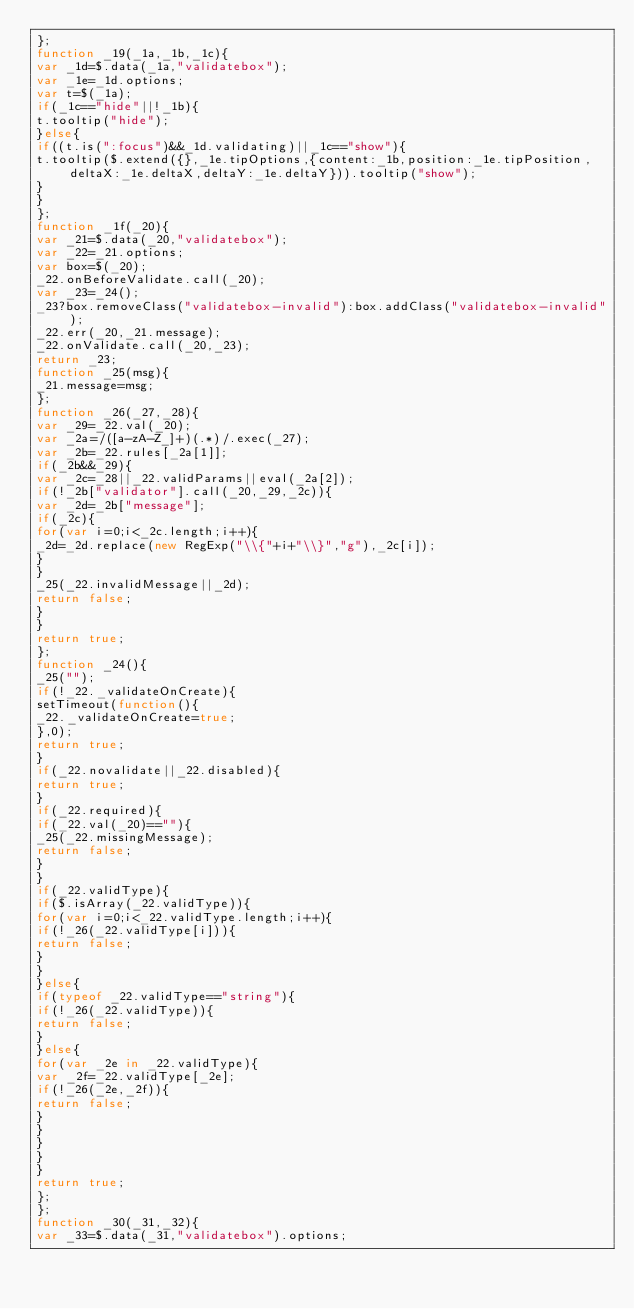<code> <loc_0><loc_0><loc_500><loc_500><_JavaScript_>};
function _19(_1a,_1b,_1c){
var _1d=$.data(_1a,"validatebox");
var _1e=_1d.options;
var t=$(_1a);
if(_1c=="hide"||!_1b){
t.tooltip("hide");
}else{
if((t.is(":focus")&&_1d.validating)||_1c=="show"){
t.tooltip($.extend({},_1e.tipOptions,{content:_1b,position:_1e.tipPosition,deltaX:_1e.deltaX,deltaY:_1e.deltaY})).tooltip("show");
}
}
};
function _1f(_20){
var _21=$.data(_20,"validatebox");
var _22=_21.options;
var box=$(_20);
_22.onBeforeValidate.call(_20);
var _23=_24();
_23?box.removeClass("validatebox-invalid"):box.addClass("validatebox-invalid");
_22.err(_20,_21.message);
_22.onValidate.call(_20,_23);
return _23;
function _25(msg){
_21.message=msg;
};
function _26(_27,_28){
var _29=_22.val(_20);
var _2a=/([a-zA-Z_]+)(.*)/.exec(_27);
var _2b=_22.rules[_2a[1]];
if(_2b&&_29){
var _2c=_28||_22.validParams||eval(_2a[2]);
if(!_2b["validator"].call(_20,_29,_2c)){
var _2d=_2b["message"];
if(_2c){
for(var i=0;i<_2c.length;i++){
_2d=_2d.replace(new RegExp("\\{"+i+"\\}","g"),_2c[i]);
}
}
_25(_22.invalidMessage||_2d);
return false;
}
}
return true;
};
function _24(){
_25("");
if(!_22._validateOnCreate){
setTimeout(function(){
_22._validateOnCreate=true;
},0);
return true;
}
if(_22.novalidate||_22.disabled){
return true;
}
if(_22.required){
if(_22.val(_20)==""){
_25(_22.missingMessage);
return false;
}
}
if(_22.validType){
if($.isArray(_22.validType)){
for(var i=0;i<_22.validType.length;i++){
if(!_26(_22.validType[i])){
return false;
}
}
}else{
if(typeof _22.validType=="string"){
if(!_26(_22.validType)){
return false;
}
}else{
for(var _2e in _22.validType){
var _2f=_22.validType[_2e];
if(!_26(_2e,_2f)){
return false;
}
}
}
}
}
return true;
};
};
function _30(_31,_32){
var _33=$.data(_31,"validatebox").options;</code> 